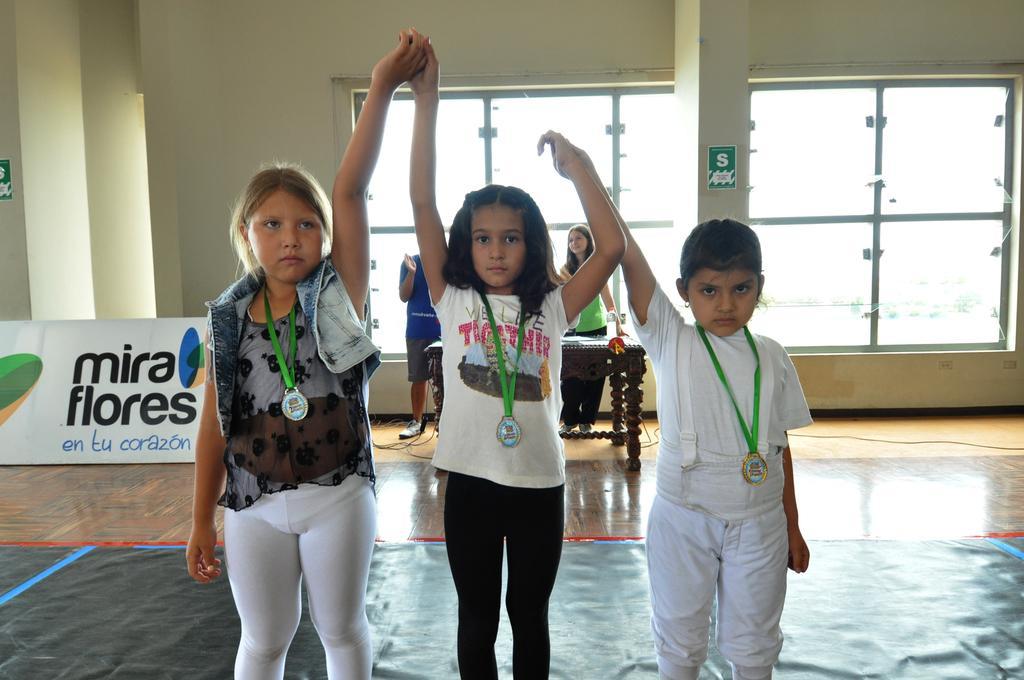Could you give a brief overview of what you see in this image? In this image we can see three children standing on the sheet which is placed on the floor. On the backside we can see a table, a man and a woman standing, some pillars, boards with some text on it, a wall and a window. 